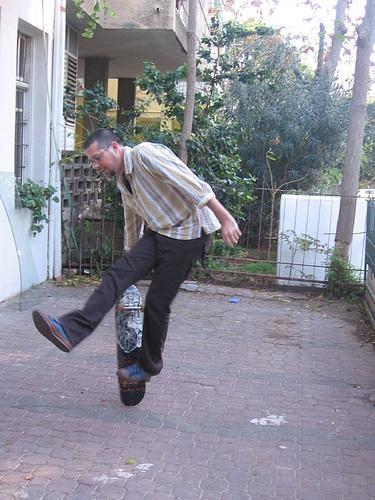How many feet are on ground?
Give a very brief answer. 0. 